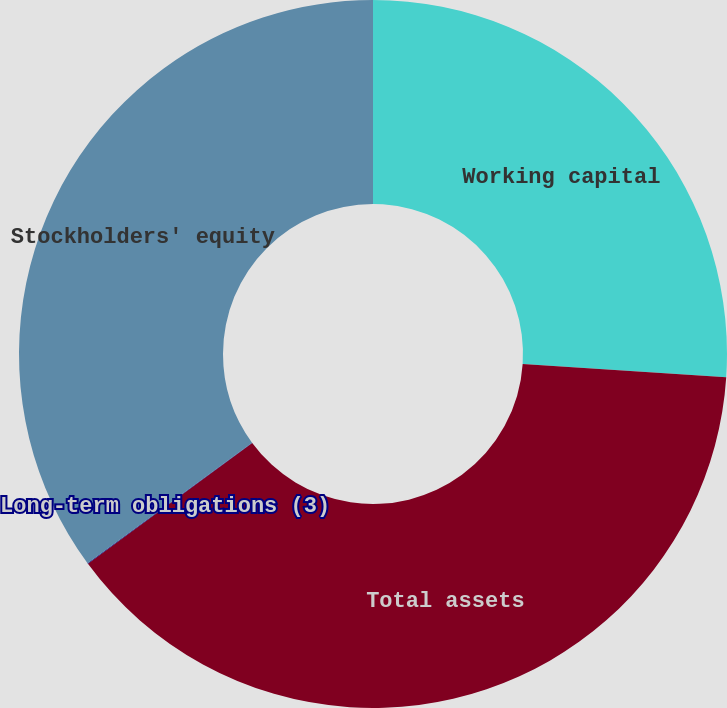Convert chart to OTSL. <chart><loc_0><loc_0><loc_500><loc_500><pie_chart><fcel>Working capital<fcel>Total assets<fcel>Long-term obligations (3)<fcel>Stockholders' equity<nl><fcel>26.05%<fcel>38.85%<fcel>0.03%<fcel>35.07%<nl></chart> 